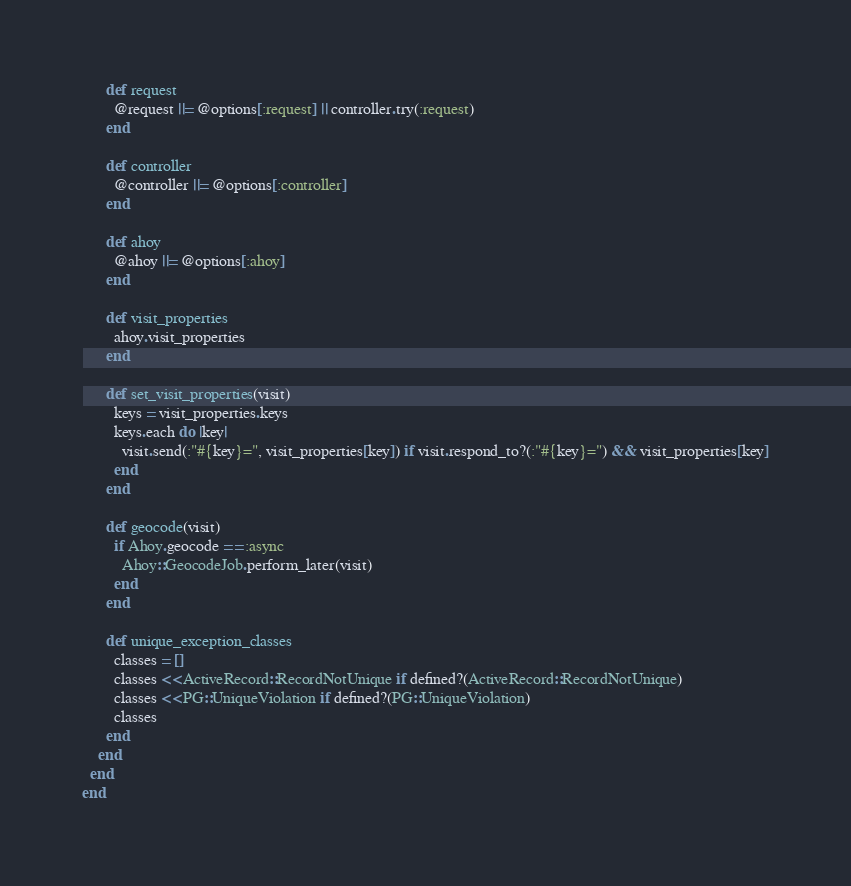Convert code to text. <code><loc_0><loc_0><loc_500><loc_500><_Ruby_>      def request
        @request ||= @options[:request] || controller.try(:request)
      end

      def controller
        @controller ||= @options[:controller]
      end

      def ahoy
        @ahoy ||= @options[:ahoy]
      end

      def visit_properties
        ahoy.visit_properties
      end

      def set_visit_properties(visit)
        keys = visit_properties.keys
        keys.each do |key|
          visit.send(:"#{key}=", visit_properties[key]) if visit.respond_to?(:"#{key}=") && visit_properties[key]
        end
      end

      def geocode(visit)
        if Ahoy.geocode == :async
          Ahoy::GeocodeJob.perform_later(visit)
        end
      end

      def unique_exception_classes
        classes = []
        classes << ActiveRecord::RecordNotUnique if defined?(ActiveRecord::RecordNotUnique)
        classes << PG::UniqueViolation if defined?(PG::UniqueViolation)
        classes
      end
    end
  end
end
</code> 